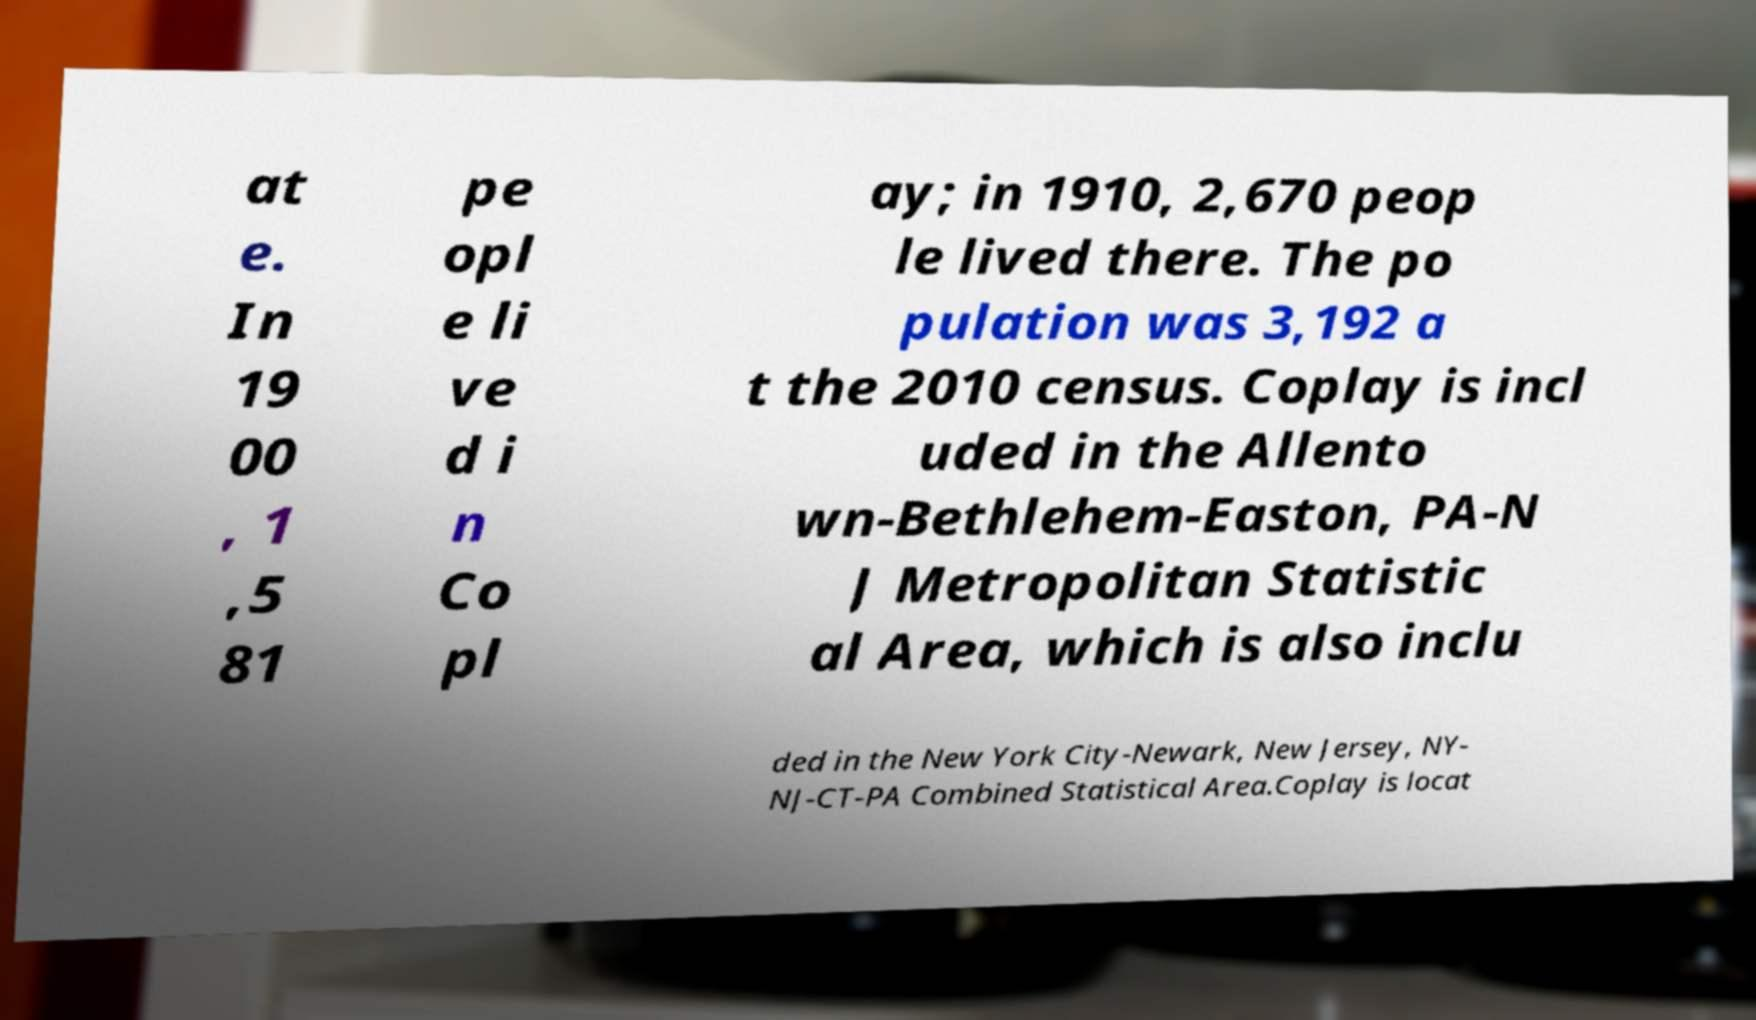Can you read and provide the text displayed in the image?This photo seems to have some interesting text. Can you extract and type it out for me? at e. In 19 00 , 1 ,5 81 pe opl e li ve d i n Co pl ay; in 1910, 2,670 peop le lived there. The po pulation was 3,192 a t the 2010 census. Coplay is incl uded in the Allento wn-Bethlehem-Easton, PA-N J Metropolitan Statistic al Area, which is also inclu ded in the New York City-Newark, New Jersey, NY- NJ-CT-PA Combined Statistical Area.Coplay is locat 